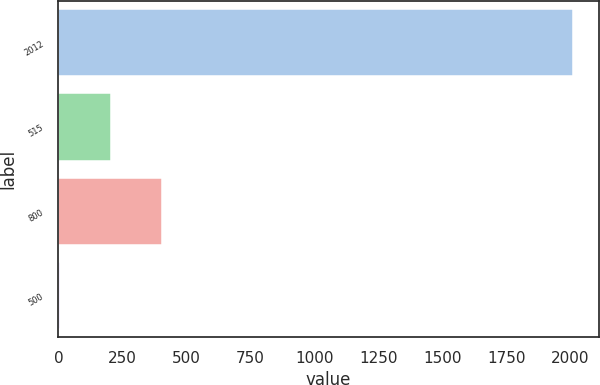Convert chart. <chart><loc_0><loc_0><loc_500><loc_500><bar_chart><fcel>2012<fcel>515<fcel>800<fcel>500<nl><fcel>2011<fcel>205.6<fcel>406.2<fcel>5<nl></chart> 